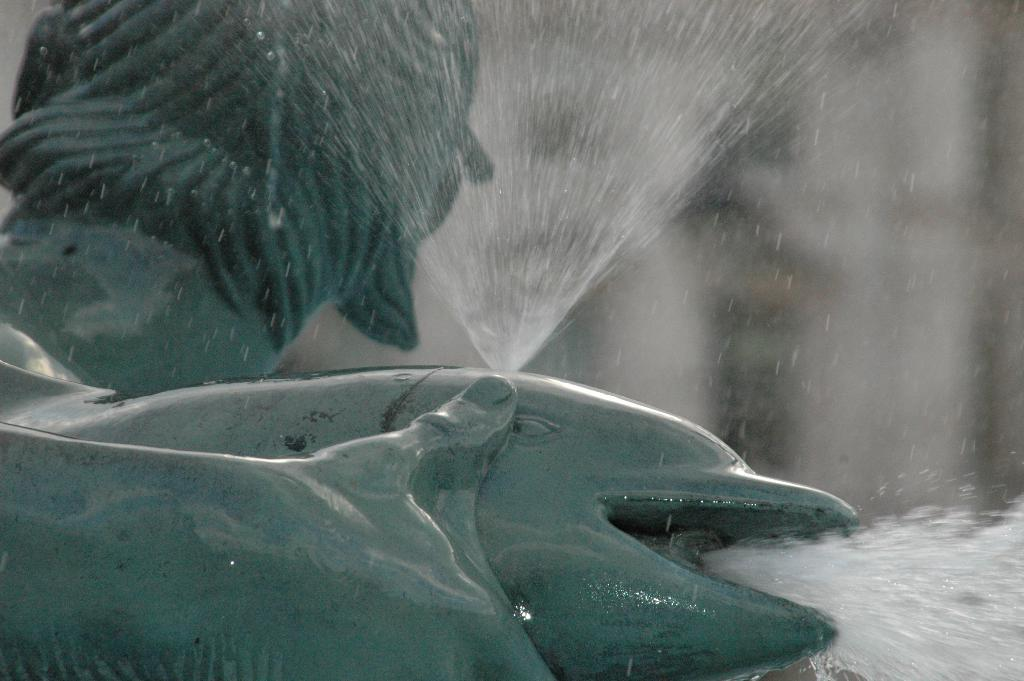What type of animals can be seen in the image? There are fishes in the image. What is the primary element in which the fishes are situated? The fishes are situated in water, which is visible in the image. Can you describe the background of the image? The background of the image is blurred. What type of crate is visible in the image? There is no crate present in the image. What town can be seen in the background of the image? There is no town visible in the image; the background is blurred. 